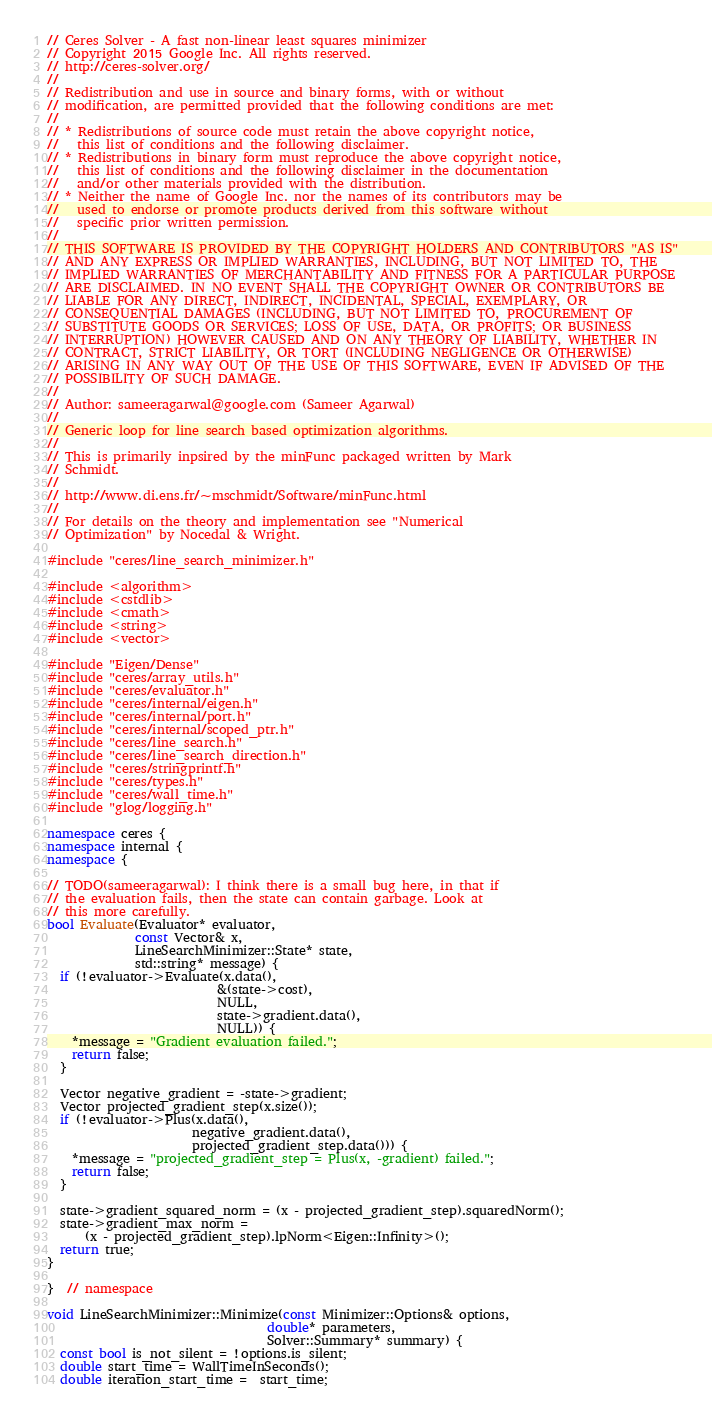<code> <loc_0><loc_0><loc_500><loc_500><_C++_>// Ceres Solver - A fast non-linear least squares minimizer
// Copyright 2015 Google Inc. All rights reserved.
// http://ceres-solver.org/
//
// Redistribution and use in source and binary forms, with or without
// modification, are permitted provided that the following conditions are met:
//
// * Redistributions of source code must retain the above copyright notice,
//   this list of conditions and the following disclaimer.
// * Redistributions in binary form must reproduce the above copyright notice,
//   this list of conditions and the following disclaimer in the documentation
//   and/or other materials provided with the distribution.
// * Neither the name of Google Inc. nor the names of its contributors may be
//   used to endorse or promote products derived from this software without
//   specific prior written permission.
//
// THIS SOFTWARE IS PROVIDED BY THE COPYRIGHT HOLDERS AND CONTRIBUTORS "AS IS"
// AND ANY EXPRESS OR IMPLIED WARRANTIES, INCLUDING, BUT NOT LIMITED TO, THE
// IMPLIED WARRANTIES OF MERCHANTABILITY AND FITNESS FOR A PARTICULAR PURPOSE
// ARE DISCLAIMED. IN NO EVENT SHALL THE COPYRIGHT OWNER OR CONTRIBUTORS BE
// LIABLE FOR ANY DIRECT, INDIRECT, INCIDENTAL, SPECIAL, EXEMPLARY, OR
// CONSEQUENTIAL DAMAGES (INCLUDING, BUT NOT LIMITED TO, PROCUREMENT OF
// SUBSTITUTE GOODS OR SERVICES; LOSS OF USE, DATA, OR PROFITS; OR BUSINESS
// INTERRUPTION) HOWEVER CAUSED AND ON ANY THEORY OF LIABILITY, WHETHER IN
// CONTRACT, STRICT LIABILITY, OR TORT (INCLUDING NEGLIGENCE OR OTHERWISE)
// ARISING IN ANY WAY OUT OF THE USE OF THIS SOFTWARE, EVEN IF ADVISED OF THE
// POSSIBILITY OF SUCH DAMAGE.
//
// Author: sameeragarwal@google.com (Sameer Agarwal)
//
// Generic loop for line search based optimization algorithms.
//
// This is primarily inpsired by the minFunc packaged written by Mark
// Schmidt.
//
// http://www.di.ens.fr/~mschmidt/Software/minFunc.html
//
// For details on the theory and implementation see "Numerical
// Optimization" by Nocedal & Wright.

#include "ceres/line_search_minimizer.h"

#include <algorithm>
#include <cstdlib>
#include <cmath>
#include <string>
#include <vector>

#include "Eigen/Dense"
#include "ceres/array_utils.h"
#include "ceres/evaluator.h"
#include "ceres/internal/eigen.h"
#include "ceres/internal/port.h"
#include "ceres/internal/scoped_ptr.h"
#include "ceres/line_search.h"
#include "ceres/line_search_direction.h"
#include "ceres/stringprintf.h"
#include "ceres/types.h"
#include "ceres/wall_time.h"
#include "glog/logging.h"

namespace ceres {
namespace internal {
namespace {

// TODO(sameeragarwal): I think there is a small bug here, in that if
// the evaluation fails, then the state can contain garbage. Look at
// this more carefully.
bool Evaluate(Evaluator* evaluator,
              const Vector& x,
              LineSearchMinimizer::State* state,
              std::string* message) {
  if (!evaluator->Evaluate(x.data(),
                           &(state->cost),
                           NULL,
                           state->gradient.data(),
                           NULL)) {
    *message = "Gradient evaluation failed.";
    return false;
  }

  Vector negative_gradient = -state->gradient;
  Vector projected_gradient_step(x.size());
  if (!evaluator->Plus(x.data(),
                       negative_gradient.data(),
                       projected_gradient_step.data())) {
    *message = "projected_gradient_step = Plus(x, -gradient) failed.";
    return false;
  }

  state->gradient_squared_norm = (x - projected_gradient_step).squaredNorm();
  state->gradient_max_norm =
      (x - projected_gradient_step).lpNorm<Eigen::Infinity>();
  return true;
}

}  // namespace

void LineSearchMinimizer::Minimize(const Minimizer::Options& options,
                                   double* parameters,
                                   Solver::Summary* summary) {
  const bool is_not_silent = !options.is_silent;
  double start_time = WallTimeInSeconds();
  double iteration_start_time =  start_time;
</code> 